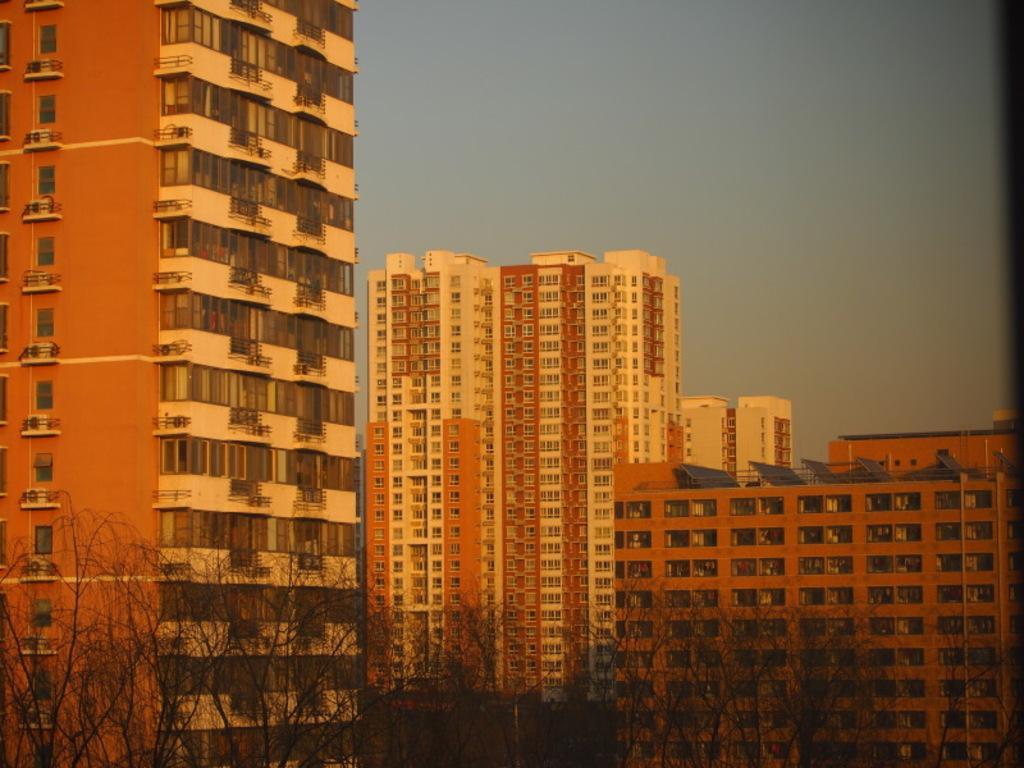In one or two sentences, can you explain what this image depicts? In this image, we can see some buildings. There are some trees at the bottom of the image. In the background of the image, there is a sky. 